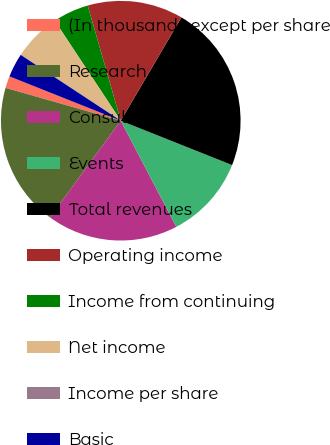Convert chart. <chart><loc_0><loc_0><loc_500><loc_500><pie_chart><fcel>(In thousands except per share<fcel>Research<fcel>Consulting<fcel>Events<fcel>Total revenues<fcel>Operating income<fcel>Income from continuing<fcel>Net income<fcel>Income per share<fcel>Basic<nl><fcel>1.61%<fcel>19.35%<fcel>17.74%<fcel>11.29%<fcel>22.58%<fcel>12.9%<fcel>4.84%<fcel>6.45%<fcel>0.0%<fcel>3.23%<nl></chart> 